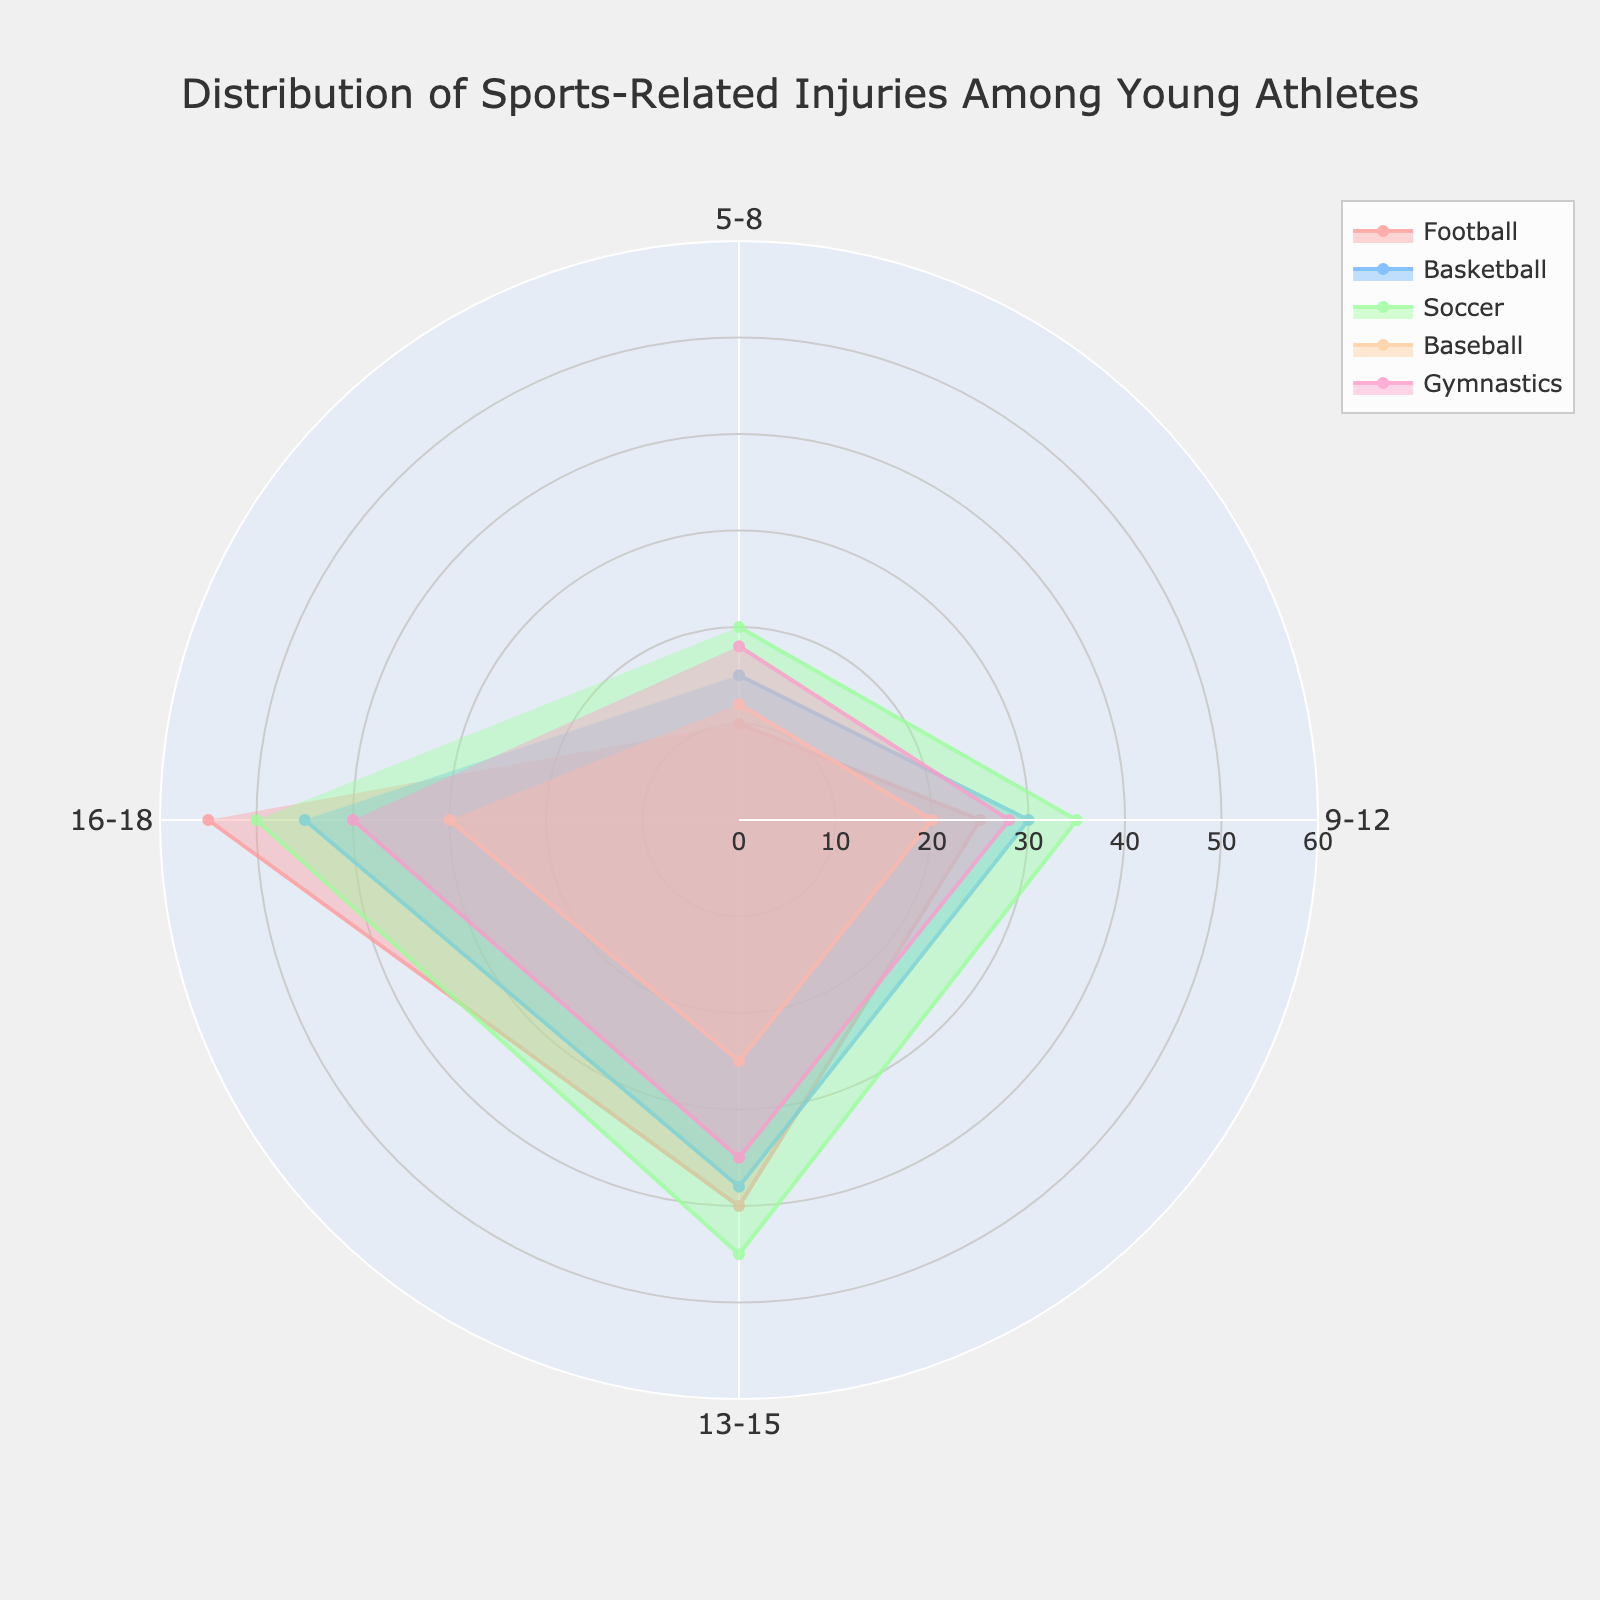What is the title of the plot? The title is usually found at the top center of the plot, written in large font to catch attention. In this case, the title is "Distribution of Sports-Related Injuries Among Young Athletes."
Answer: Distribution of Sports-Related Injuries Among Young Athletes Which age group has the highest number of football-related injuries? To find the highest number of football-related injuries across different age groups, look for the largest radial length in the football section around the polar chart. The longest value is in the 16-18 age group.
Answer: 16-18 How many sports are represented in the chart? Each segment of the fan chart represents a different sport listed in the legend. There are five segments: Football, Basketball, Soccer, Baseball, Gymnastics.
Answer: 5 Which sport has the lowest number of injuries in the 5-8 age group? Locate the 5-8 age group segment in the chart and identify the smallest radial length among the five segments. The smallest value is for Football.
Answer: Football What is the total number of injuries for the 13-15 age group? Sum the values of all sports for the 13-15 age group. Adding 40 (Football) + 38 (Basketball) + 45 (Soccer) + 25 (Baseball) + 35 (Gymnastics) gives 183.
Answer: 183 Compare the trend in soccer-related injuries across all age groups. Observe the radial length of the soccer segment in each age group. Soccer injuries increase steadily with each age group, peaking at 50 in the 16-18 age group.
Answer: Increasing trend What is the median number of injuries for gymnastics across all age groups? List the number of injuries for gymnastics: 18, 28, 35, 40. Since there are an even number of values, the median is the average of the two middle numbers. (28 + 35) / 2 = 31.5.
Answer: 31.5 During which age group do basketball injuries surpass 40? Check the value of basketball injuries for each age group. The value exceeds 40 in the 16-18 age group.
Answer: 16-18 Compare the number of soccer-related injuries between the 9-12 and 13-15 age groups. Soccer injuries are 35 in the 9-12 age group and 45 in the 13-15 age group. The difference is 45 - 35 = 10.
Answer: 10 more injuries in 13-15 than in 9-12 Explain how the distribution of injuries changes from the youngest to the oldest age group. Review the chart from the smallest to the largest age groups. Injuries in all sports generally increase with age, showing the highest values in the 16-18 age group. This indicates a trend of higher injury rates as athletes grow older.
Answer: Injuries increase with age 